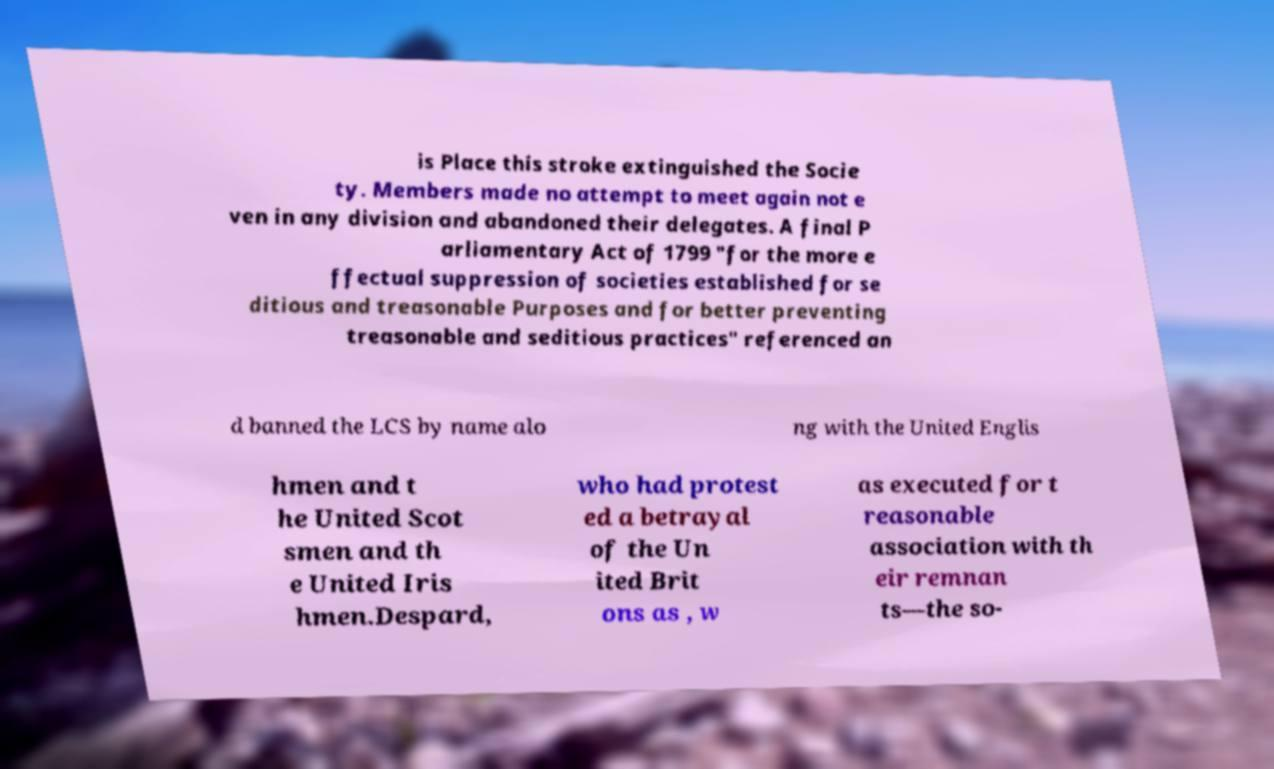Can you accurately transcribe the text from the provided image for me? is Place this stroke extinguished the Socie ty. Members made no attempt to meet again not e ven in any division and abandoned their delegates. A final P arliamentary Act of 1799 "for the more e ffectual suppression of societies established for se ditious and treasonable Purposes and for better preventing treasonable and seditious practices" referenced an d banned the LCS by name alo ng with the United Englis hmen and t he United Scot smen and th e United Iris hmen.Despard, who had protest ed a betrayal of the Un ited Brit ons as , w as executed for t reasonable association with th eir remnan ts—the so- 